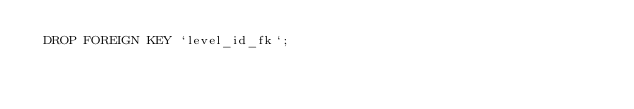Convert code to text. <code><loc_0><loc_0><loc_500><loc_500><_SQL_> DROP FOREIGN KEY `level_id_fk`;
</code> 